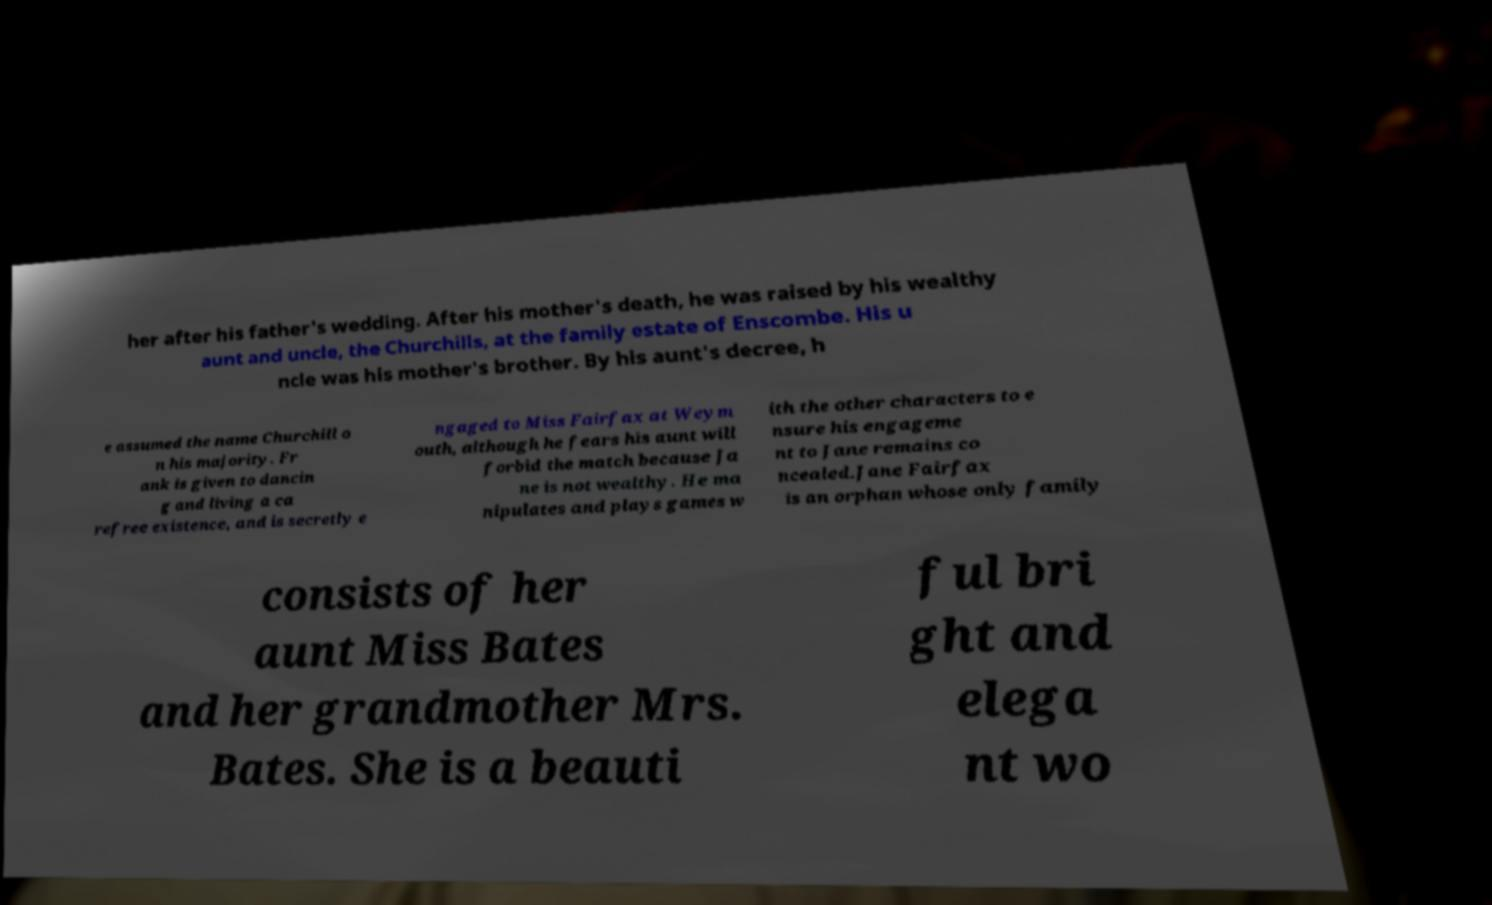Can you accurately transcribe the text from the provided image for me? her after his father's wedding. After his mother's death, he was raised by his wealthy aunt and uncle, the Churchills, at the family estate of Enscombe. His u ncle was his mother's brother. By his aunt's decree, h e assumed the name Churchill o n his majority. Fr ank is given to dancin g and living a ca refree existence, and is secretly e ngaged to Miss Fairfax at Weym outh, although he fears his aunt will forbid the match because Ja ne is not wealthy. He ma nipulates and plays games w ith the other characters to e nsure his engageme nt to Jane remains co ncealed.Jane Fairfax is an orphan whose only family consists of her aunt Miss Bates and her grandmother Mrs. Bates. She is a beauti ful bri ght and elega nt wo 